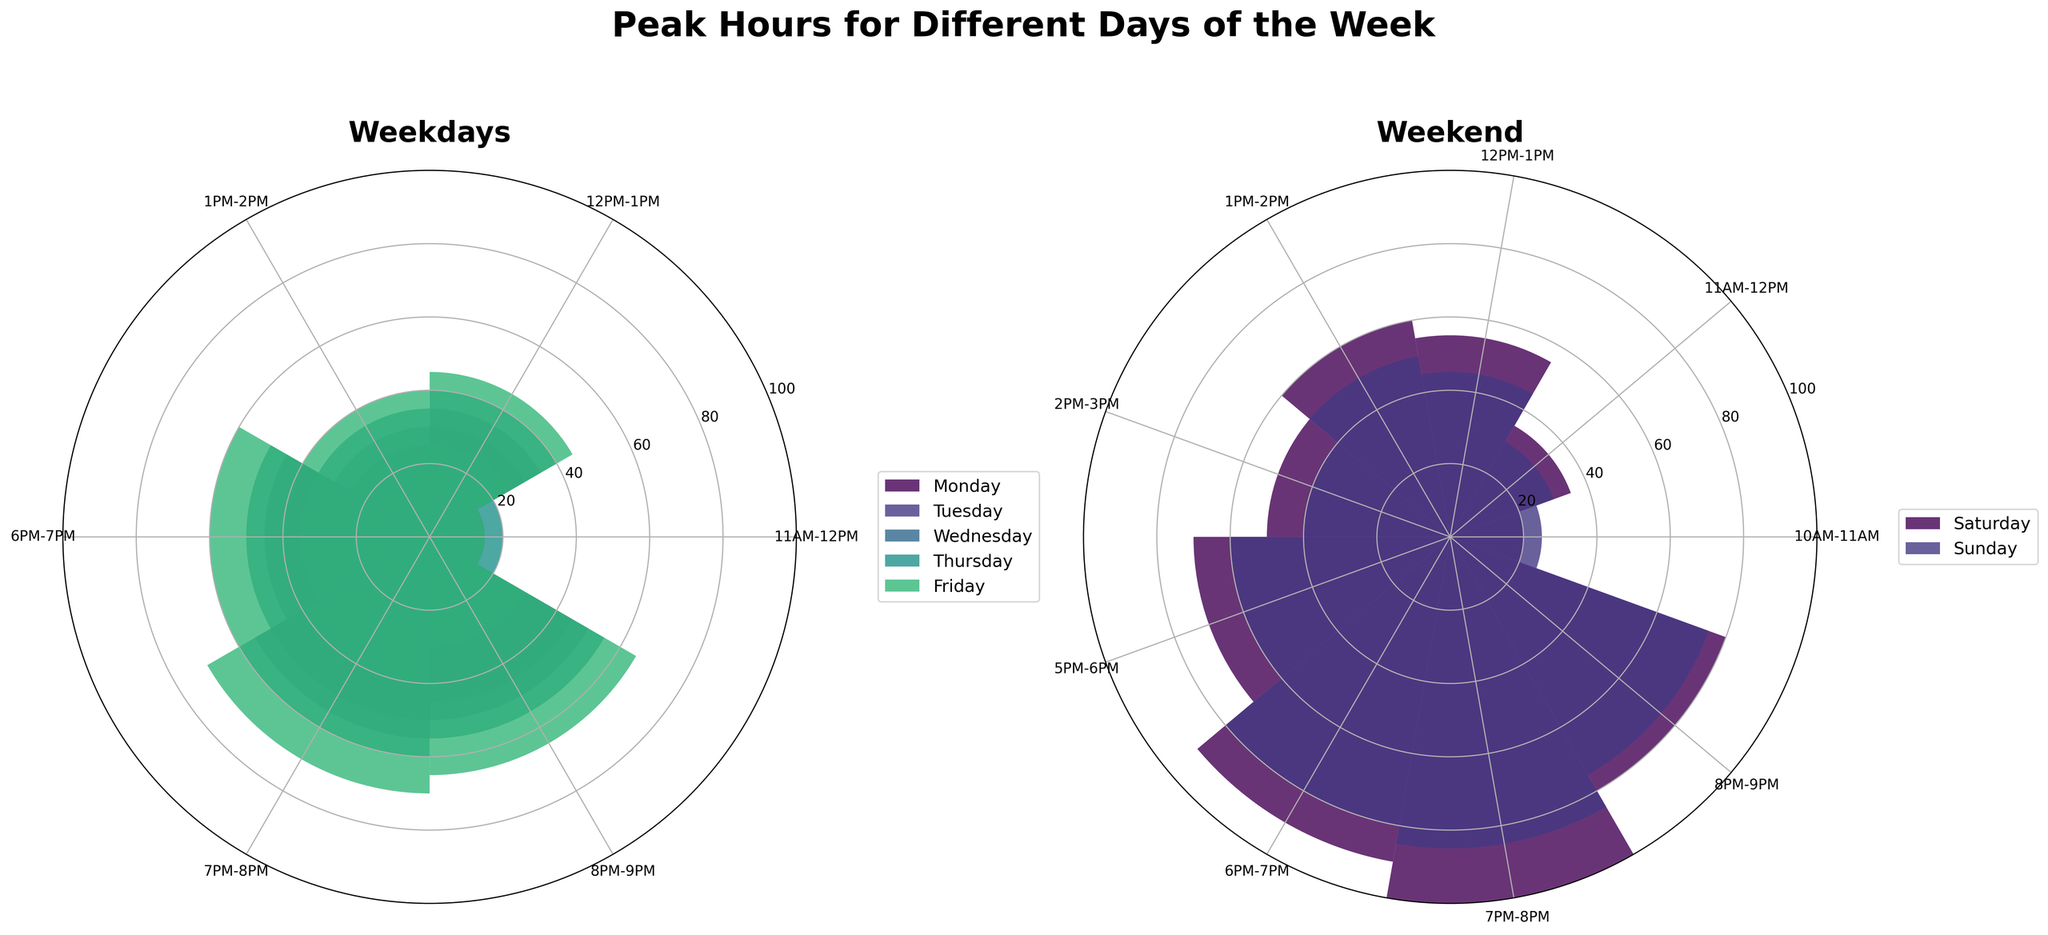Which day has the peak customer count on weekdays? To identify the peak customer count, observe the highest bar in the 'Weekdays' rose chart. The highest bar on Friday from 7PM-8PM represents 70 customers.
Answer: Friday What is the most crowded time slot on weekends? Looking at the 'Weekend' rose chart, the most crowded time slot is on Saturday from 7PM-8PM, with the highest customer count reaching 100.
Answer: 7PM-8PM on Saturday During weekdays, do more customers visit in the afternoon or evening? Summing customer counts for afternoon (11AM-2PM) and evening (6PM-9PM) slots, the evening has higher counts (e.g., Monday 135 evening vs 70 afternoon). This pattern continues for other weekdays.
Answer: Evening Comparing Saturday and Sunday evenings (6PM-9PM), which day is busier? Saturday evening (6PM-9PM) customer counts are 90, 100, and 80, totaling 270. Sunday evening counts are 80, 85, and 75, totaling 240. Thus, Saturday is busier.
Answer: Saturday What is the average customer count for Wednesday afternoons (11AM-2PM)? Summing customer counts for Wednesday afternoons (11AM-2PM), we get 12 + 25 + 30 = 67. The average is 67 / 3 ≈ 22.33.
Answer: Approximately 22.33 Is there a significant difference in the customer count between the peak hours of weekdays and weekends? Comparing peak hours, weekdays have a peak of 70 (Friday 7PM-8PM), while weekends peak at 100 (Saturday 7PM-8PM), showing a significant difference of 30 customers.
Answer: 30 customers Which day has the lowest customer count during the time slot 11AM-12PM? Observing the 11AM-12PM bars, Tuesday has the smallest value of 10 customers.
Answer: Tuesday By how much does the customer count increase from Monday's 12PM-1PM slot to Friday's 12PM-1PM slot? Monday's 12PM-1PM has 30 customers and Friday has 45 customers. The increase is 45 - 30 = 15.
Answer: 15 How does the customer count for the last evening slot (8PM-9PM) on Friday compare to that on Sunday? Friday's 8PM-9PM slot has 65 customers, and Sunday's has 75 customers. Comparing them, Sunday has 10 more customers.
Answer: 10 more customers On average, is the afternoon (12PM-1PM) busier on weekdays or weekends? Weekdays (30+35+25+40+45)/5 = 35 customers on average. Weekends (55+45)/2 = 50 customers on average. Weekends are busier.
Answer: Weekends 